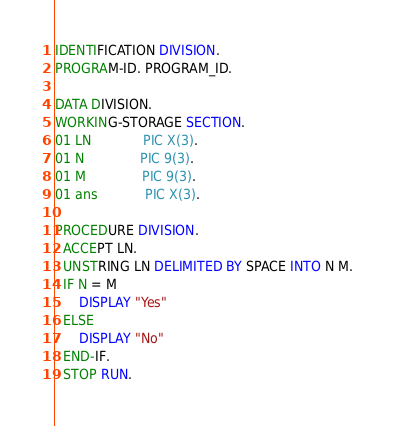Convert code to text. <code><loc_0><loc_0><loc_500><loc_500><_COBOL_>IDENTIFICATION DIVISION.
PROGRAM-ID. PROGRAM_ID.

DATA DIVISION.
WORKING-STORAGE SECTION.
01 LN             PIC X(3).
01 N              PIC 9(3).
01 M              PIC 9(3).
01 ans            PIC X(3).

PROCEDURE DIVISION.
  ACCEPT LN.
  UNSTRING LN DELIMITED BY SPACE INTO N M.
  IF N = M
      DISPLAY "Yes"
  ELSE
      DISPLAY "No"
  END-IF.
  STOP RUN.
</code> 